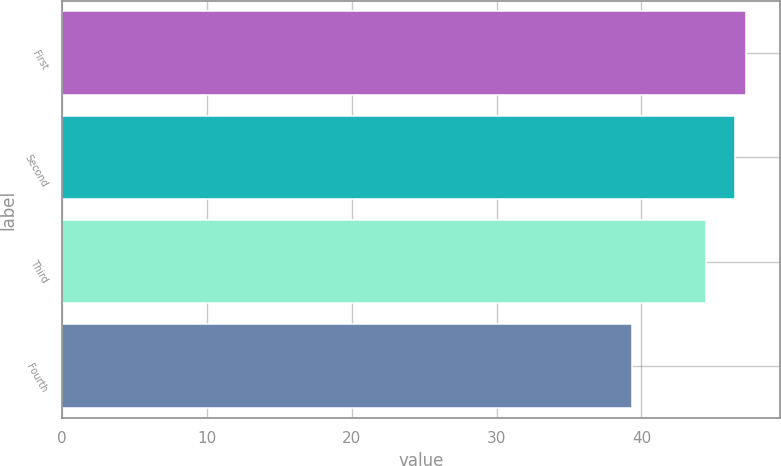Convert chart. <chart><loc_0><loc_0><loc_500><loc_500><bar_chart><fcel>First<fcel>Second<fcel>Third<fcel>Fourth<nl><fcel>47.23<fcel>46.44<fcel>44.47<fcel>39.33<nl></chart> 